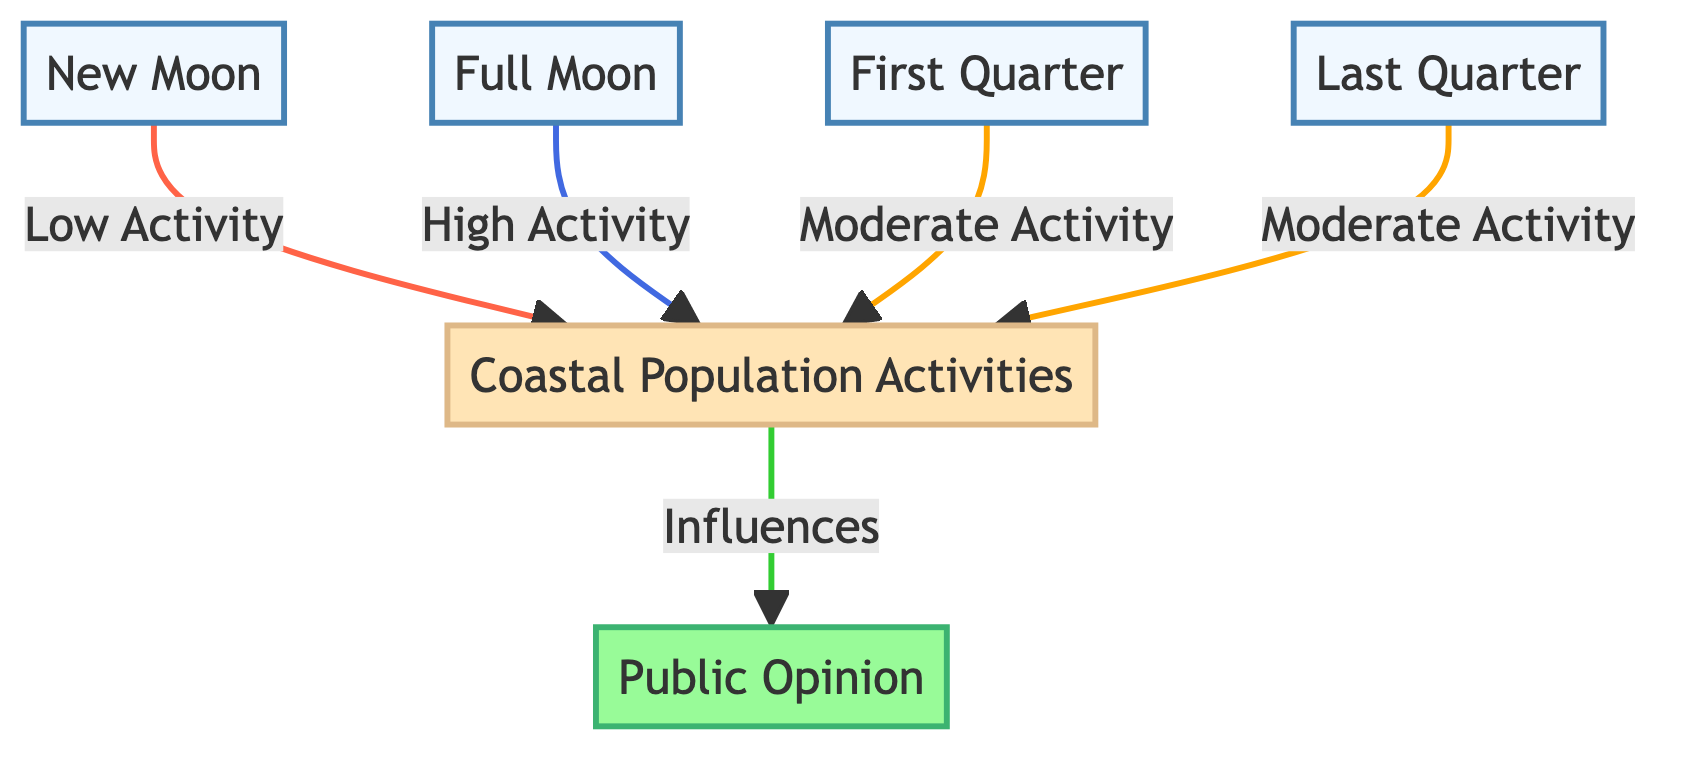What phase corresponds to low coastal activities? The "New Moon" node is directly linked to the "Coastal Population Activities" node with a label indicating "Low Activity." This shows that during the new moon phase, the coastal activities are at their lowest.
Answer: New Moon Which phase has the highest coastal activities? The "Full Moon" node is connected to the "Coastal Population Activities" node with a label that states "High Activity." This indicates that during the full moon, coastal activities peak.
Answer: Full Moon How many phases are represented in the diagram? The diagram features four moon phases: New Moon, Full Moon, First Quarter, and Last Quarter. This enumeration of the specific phases gives us the total count.
Answer: Four What type of relationship exists between coastal activities and public opinion? There is a directed relationship where the "Coastal Population Activities" node has an influence on the "Public Opinion" node, indicated by the label "Influences."
Answer: Influences Which moon phase categories show moderate activity levels? The "First Quarter" and "Last Quarter" nodes both indicate "Moderate Activity" in their respective connections to the "Coastal Population Activities" node, thus sharing this characteristic.
Answer: First Quarter, Last Quarter What is the relationship between the full moon and coastal activities? The full moon is linked to coastal activities with the label "High Activity," indicating a positive effect of the full moon on the level of activities.
Answer: High Activity Which moon phase affects public opinion directly? The "Coastal Population Activities" node influences the "Public Opinion" node, thus reflecting that the activities during the various moon phases ultimately have an effect on public sentiment.
Answer: Coastal Population Activities How many connections are there leading from moon phases to coastal activities? There are four links from the moon phases (New Moon, Full Moon, First Quarter, Last Quarter) to the coastal activities, representing each moon phase's contribution.
Answer: Four Which activity is linked to the first quarter moon? The "First Quarter" node is connected to the "Coastal Population Activities" with a label indicating "Moderate Activity," signaling the impact of this phase on coastal activities.
Answer: Moderate Activity 